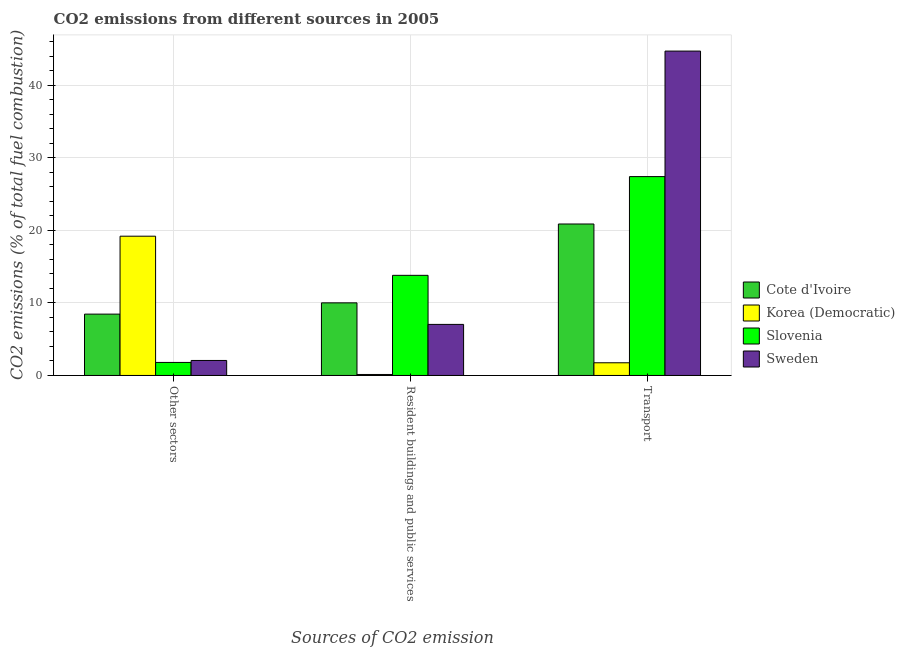How many different coloured bars are there?
Keep it short and to the point. 4. Are the number of bars per tick equal to the number of legend labels?
Your response must be concise. Yes. Are the number of bars on each tick of the X-axis equal?
Your response must be concise. Yes. How many bars are there on the 3rd tick from the left?
Offer a very short reply. 4. What is the label of the 2nd group of bars from the left?
Provide a short and direct response. Resident buildings and public services. Across all countries, what is the maximum percentage of co2 emissions from resident buildings and public services?
Keep it short and to the point. 13.79. Across all countries, what is the minimum percentage of co2 emissions from resident buildings and public services?
Your response must be concise. 0.14. In which country was the percentage of co2 emissions from resident buildings and public services maximum?
Your answer should be compact. Slovenia. In which country was the percentage of co2 emissions from transport minimum?
Offer a very short reply. Korea (Democratic). What is the total percentage of co2 emissions from resident buildings and public services in the graph?
Your response must be concise. 30.96. What is the difference between the percentage of co2 emissions from other sectors in Sweden and that in Korea (Democratic)?
Keep it short and to the point. -17.12. What is the difference between the percentage of co2 emissions from other sectors in Cote d'Ivoire and the percentage of co2 emissions from resident buildings and public services in Slovenia?
Offer a very short reply. -5.34. What is the average percentage of co2 emissions from other sectors per country?
Give a very brief answer. 7.87. What is the difference between the percentage of co2 emissions from other sectors and percentage of co2 emissions from transport in Slovenia?
Offer a terse response. -25.59. In how many countries, is the percentage of co2 emissions from other sectors greater than 42 %?
Offer a terse response. 0. What is the ratio of the percentage of co2 emissions from other sectors in Sweden to that in Cote d'Ivoire?
Ensure brevity in your answer.  0.24. Is the percentage of co2 emissions from resident buildings and public services in Sweden less than that in Cote d'Ivoire?
Your response must be concise. Yes. Is the difference between the percentage of co2 emissions from other sectors in Korea (Democratic) and Slovenia greater than the difference between the percentage of co2 emissions from resident buildings and public services in Korea (Democratic) and Slovenia?
Your answer should be compact. Yes. What is the difference between the highest and the second highest percentage of co2 emissions from other sectors?
Provide a succinct answer. 10.73. What is the difference between the highest and the lowest percentage of co2 emissions from transport?
Make the answer very short. 42.93. Is the sum of the percentage of co2 emissions from resident buildings and public services in Cote d'Ivoire and Slovenia greater than the maximum percentage of co2 emissions from other sectors across all countries?
Your answer should be compact. Yes. What does the 1st bar from the left in Transport represents?
Keep it short and to the point. Cote d'Ivoire. What does the 4th bar from the right in Other sectors represents?
Your answer should be very brief. Cote d'Ivoire. Are all the bars in the graph horizontal?
Offer a very short reply. No. What is the difference between two consecutive major ticks on the Y-axis?
Make the answer very short. 10. Does the graph contain any zero values?
Provide a succinct answer. No. Does the graph contain grids?
Offer a terse response. Yes. Where does the legend appear in the graph?
Your answer should be compact. Center right. What is the title of the graph?
Make the answer very short. CO2 emissions from different sources in 2005. Does "Palau" appear as one of the legend labels in the graph?
Offer a very short reply. No. What is the label or title of the X-axis?
Give a very brief answer. Sources of CO2 emission. What is the label or title of the Y-axis?
Offer a very short reply. CO2 emissions (% of total fuel combustion). What is the CO2 emissions (% of total fuel combustion) of Cote d'Ivoire in Other sectors?
Offer a terse response. 8.45. What is the CO2 emissions (% of total fuel combustion) of Korea (Democratic) in Other sectors?
Give a very brief answer. 19.18. What is the CO2 emissions (% of total fuel combustion) in Slovenia in Other sectors?
Give a very brief answer. 1.8. What is the CO2 emissions (% of total fuel combustion) in Sweden in Other sectors?
Your answer should be very brief. 2.07. What is the CO2 emissions (% of total fuel combustion) of Cote d'Ivoire in Resident buildings and public services?
Keep it short and to the point. 10. What is the CO2 emissions (% of total fuel combustion) in Korea (Democratic) in Resident buildings and public services?
Your answer should be very brief. 0.14. What is the CO2 emissions (% of total fuel combustion) of Slovenia in Resident buildings and public services?
Provide a succinct answer. 13.79. What is the CO2 emissions (% of total fuel combustion) of Sweden in Resident buildings and public services?
Your answer should be very brief. 7.03. What is the CO2 emissions (% of total fuel combustion) in Cote d'Ivoire in Transport?
Provide a short and direct response. 20.86. What is the CO2 emissions (% of total fuel combustion) of Korea (Democratic) in Transport?
Give a very brief answer. 1.75. What is the CO2 emissions (% of total fuel combustion) in Slovenia in Transport?
Ensure brevity in your answer.  27.39. What is the CO2 emissions (% of total fuel combustion) in Sweden in Transport?
Offer a very short reply. 44.68. Across all Sources of CO2 emission, what is the maximum CO2 emissions (% of total fuel combustion) in Cote d'Ivoire?
Ensure brevity in your answer.  20.86. Across all Sources of CO2 emission, what is the maximum CO2 emissions (% of total fuel combustion) in Korea (Democratic)?
Ensure brevity in your answer.  19.18. Across all Sources of CO2 emission, what is the maximum CO2 emissions (% of total fuel combustion) in Slovenia?
Provide a succinct answer. 27.39. Across all Sources of CO2 emission, what is the maximum CO2 emissions (% of total fuel combustion) of Sweden?
Your answer should be compact. 44.68. Across all Sources of CO2 emission, what is the minimum CO2 emissions (% of total fuel combustion) of Cote d'Ivoire?
Give a very brief answer. 8.45. Across all Sources of CO2 emission, what is the minimum CO2 emissions (% of total fuel combustion) in Korea (Democratic)?
Your answer should be compact. 0.14. Across all Sources of CO2 emission, what is the minimum CO2 emissions (% of total fuel combustion) of Slovenia?
Provide a succinct answer. 1.8. Across all Sources of CO2 emission, what is the minimum CO2 emissions (% of total fuel combustion) of Sweden?
Make the answer very short. 2.07. What is the total CO2 emissions (% of total fuel combustion) in Cote d'Ivoire in the graph?
Give a very brief answer. 39.31. What is the total CO2 emissions (% of total fuel combustion) of Korea (Democratic) in the graph?
Your answer should be very brief. 21.06. What is the total CO2 emissions (% of total fuel combustion) in Slovenia in the graph?
Provide a succinct answer. 42.98. What is the total CO2 emissions (% of total fuel combustion) of Sweden in the graph?
Provide a succinct answer. 53.77. What is the difference between the CO2 emissions (% of total fuel combustion) in Cote d'Ivoire in Other sectors and that in Resident buildings and public services?
Your response must be concise. -1.55. What is the difference between the CO2 emissions (% of total fuel combustion) in Korea (Democratic) in Other sectors and that in Resident buildings and public services?
Your response must be concise. 19.05. What is the difference between the CO2 emissions (% of total fuel combustion) of Slovenia in Other sectors and that in Resident buildings and public services?
Keep it short and to the point. -11.99. What is the difference between the CO2 emissions (% of total fuel combustion) in Sweden in Other sectors and that in Resident buildings and public services?
Make the answer very short. -4.97. What is the difference between the CO2 emissions (% of total fuel combustion) of Cote d'Ivoire in Other sectors and that in Transport?
Your response must be concise. -12.41. What is the difference between the CO2 emissions (% of total fuel combustion) in Korea (Democratic) in Other sectors and that in Transport?
Give a very brief answer. 17.43. What is the difference between the CO2 emissions (% of total fuel combustion) in Slovenia in Other sectors and that in Transport?
Ensure brevity in your answer.  -25.59. What is the difference between the CO2 emissions (% of total fuel combustion) of Sweden in Other sectors and that in Transport?
Offer a terse response. -42.61. What is the difference between the CO2 emissions (% of total fuel combustion) in Cote d'Ivoire in Resident buildings and public services and that in Transport?
Offer a very short reply. -10.86. What is the difference between the CO2 emissions (% of total fuel combustion) in Korea (Democratic) in Resident buildings and public services and that in Transport?
Provide a short and direct response. -1.61. What is the difference between the CO2 emissions (% of total fuel combustion) in Slovenia in Resident buildings and public services and that in Transport?
Provide a short and direct response. -13.6. What is the difference between the CO2 emissions (% of total fuel combustion) in Sweden in Resident buildings and public services and that in Transport?
Provide a short and direct response. -37.64. What is the difference between the CO2 emissions (% of total fuel combustion) in Cote d'Ivoire in Other sectors and the CO2 emissions (% of total fuel combustion) in Korea (Democratic) in Resident buildings and public services?
Your answer should be compact. 8.31. What is the difference between the CO2 emissions (% of total fuel combustion) of Cote d'Ivoire in Other sectors and the CO2 emissions (% of total fuel combustion) of Slovenia in Resident buildings and public services?
Your answer should be very brief. -5.34. What is the difference between the CO2 emissions (% of total fuel combustion) of Cote d'Ivoire in Other sectors and the CO2 emissions (% of total fuel combustion) of Sweden in Resident buildings and public services?
Provide a short and direct response. 1.42. What is the difference between the CO2 emissions (% of total fuel combustion) in Korea (Democratic) in Other sectors and the CO2 emissions (% of total fuel combustion) in Slovenia in Resident buildings and public services?
Give a very brief answer. 5.39. What is the difference between the CO2 emissions (% of total fuel combustion) of Korea (Democratic) in Other sectors and the CO2 emissions (% of total fuel combustion) of Sweden in Resident buildings and public services?
Make the answer very short. 12.15. What is the difference between the CO2 emissions (% of total fuel combustion) in Slovenia in Other sectors and the CO2 emissions (% of total fuel combustion) in Sweden in Resident buildings and public services?
Ensure brevity in your answer.  -5.24. What is the difference between the CO2 emissions (% of total fuel combustion) in Cote d'Ivoire in Other sectors and the CO2 emissions (% of total fuel combustion) in Korea (Democratic) in Transport?
Provide a short and direct response. 6.7. What is the difference between the CO2 emissions (% of total fuel combustion) of Cote d'Ivoire in Other sectors and the CO2 emissions (% of total fuel combustion) of Slovenia in Transport?
Provide a succinct answer. -18.94. What is the difference between the CO2 emissions (% of total fuel combustion) of Cote d'Ivoire in Other sectors and the CO2 emissions (% of total fuel combustion) of Sweden in Transport?
Ensure brevity in your answer.  -36.23. What is the difference between the CO2 emissions (% of total fuel combustion) of Korea (Democratic) in Other sectors and the CO2 emissions (% of total fuel combustion) of Slovenia in Transport?
Offer a terse response. -8.21. What is the difference between the CO2 emissions (% of total fuel combustion) of Korea (Democratic) in Other sectors and the CO2 emissions (% of total fuel combustion) of Sweden in Transport?
Provide a succinct answer. -25.49. What is the difference between the CO2 emissions (% of total fuel combustion) in Slovenia in Other sectors and the CO2 emissions (% of total fuel combustion) in Sweden in Transport?
Provide a short and direct response. -42.88. What is the difference between the CO2 emissions (% of total fuel combustion) in Cote d'Ivoire in Resident buildings and public services and the CO2 emissions (% of total fuel combustion) in Korea (Democratic) in Transport?
Ensure brevity in your answer.  8.25. What is the difference between the CO2 emissions (% of total fuel combustion) of Cote d'Ivoire in Resident buildings and public services and the CO2 emissions (% of total fuel combustion) of Slovenia in Transport?
Your answer should be very brief. -17.39. What is the difference between the CO2 emissions (% of total fuel combustion) in Cote d'Ivoire in Resident buildings and public services and the CO2 emissions (% of total fuel combustion) in Sweden in Transport?
Make the answer very short. -34.68. What is the difference between the CO2 emissions (% of total fuel combustion) in Korea (Democratic) in Resident buildings and public services and the CO2 emissions (% of total fuel combustion) in Slovenia in Transport?
Make the answer very short. -27.25. What is the difference between the CO2 emissions (% of total fuel combustion) of Korea (Democratic) in Resident buildings and public services and the CO2 emissions (% of total fuel combustion) of Sweden in Transport?
Keep it short and to the point. -44.54. What is the difference between the CO2 emissions (% of total fuel combustion) of Slovenia in Resident buildings and public services and the CO2 emissions (% of total fuel combustion) of Sweden in Transport?
Provide a succinct answer. -30.89. What is the average CO2 emissions (% of total fuel combustion) in Cote d'Ivoire per Sources of CO2 emission?
Your answer should be very brief. 13.1. What is the average CO2 emissions (% of total fuel combustion) of Korea (Democratic) per Sources of CO2 emission?
Provide a succinct answer. 7.02. What is the average CO2 emissions (% of total fuel combustion) of Slovenia per Sources of CO2 emission?
Give a very brief answer. 14.33. What is the average CO2 emissions (% of total fuel combustion) in Sweden per Sources of CO2 emission?
Your response must be concise. 17.92. What is the difference between the CO2 emissions (% of total fuel combustion) in Cote d'Ivoire and CO2 emissions (% of total fuel combustion) in Korea (Democratic) in Other sectors?
Your answer should be very brief. -10.73. What is the difference between the CO2 emissions (% of total fuel combustion) of Cote d'Ivoire and CO2 emissions (% of total fuel combustion) of Slovenia in Other sectors?
Your response must be concise. 6.65. What is the difference between the CO2 emissions (% of total fuel combustion) of Cote d'Ivoire and CO2 emissions (% of total fuel combustion) of Sweden in Other sectors?
Your answer should be compact. 6.38. What is the difference between the CO2 emissions (% of total fuel combustion) of Korea (Democratic) and CO2 emissions (% of total fuel combustion) of Slovenia in Other sectors?
Provide a short and direct response. 17.39. What is the difference between the CO2 emissions (% of total fuel combustion) of Korea (Democratic) and CO2 emissions (% of total fuel combustion) of Sweden in Other sectors?
Offer a terse response. 17.12. What is the difference between the CO2 emissions (% of total fuel combustion) of Slovenia and CO2 emissions (% of total fuel combustion) of Sweden in Other sectors?
Offer a terse response. -0.27. What is the difference between the CO2 emissions (% of total fuel combustion) of Cote d'Ivoire and CO2 emissions (% of total fuel combustion) of Korea (Democratic) in Resident buildings and public services?
Provide a short and direct response. 9.86. What is the difference between the CO2 emissions (% of total fuel combustion) of Cote d'Ivoire and CO2 emissions (% of total fuel combustion) of Slovenia in Resident buildings and public services?
Your response must be concise. -3.79. What is the difference between the CO2 emissions (% of total fuel combustion) in Cote d'Ivoire and CO2 emissions (% of total fuel combustion) in Sweden in Resident buildings and public services?
Provide a succinct answer. 2.97. What is the difference between the CO2 emissions (% of total fuel combustion) in Korea (Democratic) and CO2 emissions (% of total fuel combustion) in Slovenia in Resident buildings and public services?
Make the answer very short. -13.66. What is the difference between the CO2 emissions (% of total fuel combustion) in Korea (Democratic) and CO2 emissions (% of total fuel combustion) in Sweden in Resident buildings and public services?
Your answer should be very brief. -6.9. What is the difference between the CO2 emissions (% of total fuel combustion) of Slovenia and CO2 emissions (% of total fuel combustion) of Sweden in Resident buildings and public services?
Your response must be concise. 6.76. What is the difference between the CO2 emissions (% of total fuel combustion) of Cote d'Ivoire and CO2 emissions (% of total fuel combustion) of Korea (Democratic) in Transport?
Provide a short and direct response. 19.11. What is the difference between the CO2 emissions (% of total fuel combustion) of Cote d'Ivoire and CO2 emissions (% of total fuel combustion) of Slovenia in Transport?
Your response must be concise. -6.53. What is the difference between the CO2 emissions (% of total fuel combustion) of Cote d'Ivoire and CO2 emissions (% of total fuel combustion) of Sweden in Transport?
Keep it short and to the point. -23.81. What is the difference between the CO2 emissions (% of total fuel combustion) of Korea (Democratic) and CO2 emissions (% of total fuel combustion) of Slovenia in Transport?
Make the answer very short. -25.64. What is the difference between the CO2 emissions (% of total fuel combustion) of Korea (Democratic) and CO2 emissions (% of total fuel combustion) of Sweden in Transport?
Your answer should be compact. -42.93. What is the difference between the CO2 emissions (% of total fuel combustion) of Slovenia and CO2 emissions (% of total fuel combustion) of Sweden in Transport?
Ensure brevity in your answer.  -17.29. What is the ratio of the CO2 emissions (% of total fuel combustion) in Cote d'Ivoire in Other sectors to that in Resident buildings and public services?
Your response must be concise. 0.84. What is the ratio of the CO2 emissions (% of total fuel combustion) of Korea (Democratic) in Other sectors to that in Resident buildings and public services?
Your response must be concise. 141.6. What is the ratio of the CO2 emissions (% of total fuel combustion) in Slovenia in Other sectors to that in Resident buildings and public services?
Keep it short and to the point. 0.13. What is the ratio of the CO2 emissions (% of total fuel combustion) of Sweden in Other sectors to that in Resident buildings and public services?
Your response must be concise. 0.29. What is the ratio of the CO2 emissions (% of total fuel combustion) in Cote d'Ivoire in Other sectors to that in Transport?
Give a very brief answer. 0.41. What is the ratio of the CO2 emissions (% of total fuel combustion) in Korea (Democratic) in Other sectors to that in Transport?
Offer a terse response. 10.98. What is the ratio of the CO2 emissions (% of total fuel combustion) of Slovenia in Other sectors to that in Transport?
Provide a short and direct response. 0.07. What is the ratio of the CO2 emissions (% of total fuel combustion) in Sweden in Other sectors to that in Transport?
Give a very brief answer. 0.05. What is the ratio of the CO2 emissions (% of total fuel combustion) in Cote d'Ivoire in Resident buildings and public services to that in Transport?
Offer a terse response. 0.48. What is the ratio of the CO2 emissions (% of total fuel combustion) in Korea (Democratic) in Resident buildings and public services to that in Transport?
Give a very brief answer. 0.08. What is the ratio of the CO2 emissions (% of total fuel combustion) of Slovenia in Resident buildings and public services to that in Transport?
Provide a succinct answer. 0.5. What is the ratio of the CO2 emissions (% of total fuel combustion) in Sweden in Resident buildings and public services to that in Transport?
Keep it short and to the point. 0.16. What is the difference between the highest and the second highest CO2 emissions (% of total fuel combustion) of Cote d'Ivoire?
Offer a very short reply. 10.86. What is the difference between the highest and the second highest CO2 emissions (% of total fuel combustion) in Korea (Democratic)?
Keep it short and to the point. 17.43. What is the difference between the highest and the second highest CO2 emissions (% of total fuel combustion) in Slovenia?
Your answer should be very brief. 13.6. What is the difference between the highest and the second highest CO2 emissions (% of total fuel combustion) in Sweden?
Ensure brevity in your answer.  37.64. What is the difference between the highest and the lowest CO2 emissions (% of total fuel combustion) of Cote d'Ivoire?
Make the answer very short. 12.41. What is the difference between the highest and the lowest CO2 emissions (% of total fuel combustion) in Korea (Democratic)?
Your answer should be very brief. 19.05. What is the difference between the highest and the lowest CO2 emissions (% of total fuel combustion) in Slovenia?
Your answer should be very brief. 25.59. What is the difference between the highest and the lowest CO2 emissions (% of total fuel combustion) of Sweden?
Give a very brief answer. 42.61. 